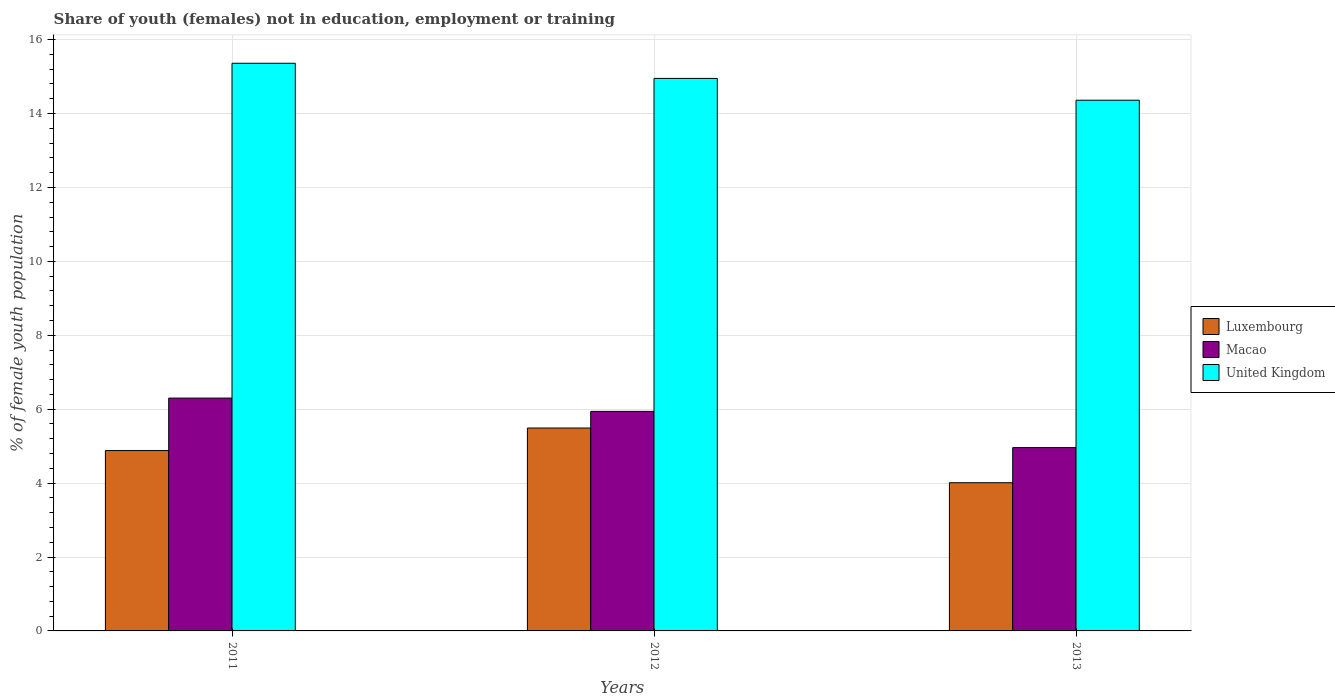How many bars are there on the 2nd tick from the left?
Make the answer very short. 3. What is the label of the 2nd group of bars from the left?
Your response must be concise. 2012. In how many cases, is the number of bars for a given year not equal to the number of legend labels?
Your answer should be very brief. 0. What is the percentage of unemployed female population in in United Kingdom in 2013?
Keep it short and to the point. 14.36. Across all years, what is the maximum percentage of unemployed female population in in Macao?
Provide a succinct answer. 6.3. Across all years, what is the minimum percentage of unemployed female population in in Macao?
Your response must be concise. 4.96. What is the total percentage of unemployed female population in in United Kingdom in the graph?
Your response must be concise. 44.67. What is the difference between the percentage of unemployed female population in in United Kingdom in 2011 and that in 2012?
Your response must be concise. 0.41. What is the difference between the percentage of unemployed female population in in Luxembourg in 2011 and the percentage of unemployed female population in in Macao in 2012?
Provide a succinct answer. -1.06. What is the average percentage of unemployed female population in in Luxembourg per year?
Offer a terse response. 4.79. In the year 2012, what is the difference between the percentage of unemployed female population in in Luxembourg and percentage of unemployed female population in in Macao?
Keep it short and to the point. -0.45. In how many years, is the percentage of unemployed female population in in Luxembourg greater than 12.8 %?
Provide a succinct answer. 0. What is the ratio of the percentage of unemployed female population in in Luxembourg in 2012 to that in 2013?
Keep it short and to the point. 1.37. Is the percentage of unemployed female population in in United Kingdom in 2012 less than that in 2013?
Offer a terse response. No. Is the difference between the percentage of unemployed female population in in Luxembourg in 2011 and 2012 greater than the difference between the percentage of unemployed female population in in Macao in 2011 and 2012?
Your answer should be very brief. No. What is the difference between the highest and the second highest percentage of unemployed female population in in Macao?
Make the answer very short. 0.36. What is the difference between the highest and the lowest percentage of unemployed female population in in Luxembourg?
Your response must be concise. 1.48. In how many years, is the percentage of unemployed female population in in United Kingdom greater than the average percentage of unemployed female population in in United Kingdom taken over all years?
Keep it short and to the point. 2. Is the sum of the percentage of unemployed female population in in Macao in 2011 and 2012 greater than the maximum percentage of unemployed female population in in Luxembourg across all years?
Your answer should be compact. Yes. What does the 2nd bar from the left in 2013 represents?
Offer a very short reply. Macao. What does the 1st bar from the right in 2012 represents?
Make the answer very short. United Kingdom. Is it the case that in every year, the sum of the percentage of unemployed female population in in Macao and percentage of unemployed female population in in Luxembourg is greater than the percentage of unemployed female population in in United Kingdom?
Your answer should be very brief. No. How many years are there in the graph?
Ensure brevity in your answer.  3. What is the difference between two consecutive major ticks on the Y-axis?
Ensure brevity in your answer.  2. Are the values on the major ticks of Y-axis written in scientific E-notation?
Offer a terse response. No. What is the title of the graph?
Your answer should be very brief. Share of youth (females) not in education, employment or training. Does "Low & middle income" appear as one of the legend labels in the graph?
Offer a terse response. No. What is the label or title of the X-axis?
Give a very brief answer. Years. What is the label or title of the Y-axis?
Your answer should be very brief. % of female youth population. What is the % of female youth population in Luxembourg in 2011?
Offer a terse response. 4.88. What is the % of female youth population of Macao in 2011?
Give a very brief answer. 6.3. What is the % of female youth population in United Kingdom in 2011?
Your answer should be compact. 15.36. What is the % of female youth population of Luxembourg in 2012?
Offer a terse response. 5.49. What is the % of female youth population in Macao in 2012?
Your answer should be very brief. 5.94. What is the % of female youth population in United Kingdom in 2012?
Keep it short and to the point. 14.95. What is the % of female youth population of Luxembourg in 2013?
Ensure brevity in your answer.  4.01. What is the % of female youth population in Macao in 2013?
Give a very brief answer. 4.96. What is the % of female youth population of United Kingdom in 2013?
Make the answer very short. 14.36. Across all years, what is the maximum % of female youth population in Luxembourg?
Make the answer very short. 5.49. Across all years, what is the maximum % of female youth population in Macao?
Your answer should be very brief. 6.3. Across all years, what is the maximum % of female youth population of United Kingdom?
Offer a very short reply. 15.36. Across all years, what is the minimum % of female youth population in Luxembourg?
Keep it short and to the point. 4.01. Across all years, what is the minimum % of female youth population in Macao?
Offer a terse response. 4.96. Across all years, what is the minimum % of female youth population in United Kingdom?
Make the answer very short. 14.36. What is the total % of female youth population in Luxembourg in the graph?
Your answer should be very brief. 14.38. What is the total % of female youth population of Macao in the graph?
Offer a terse response. 17.2. What is the total % of female youth population in United Kingdom in the graph?
Keep it short and to the point. 44.67. What is the difference between the % of female youth population of Luxembourg in 2011 and that in 2012?
Your answer should be very brief. -0.61. What is the difference between the % of female youth population in Macao in 2011 and that in 2012?
Provide a short and direct response. 0.36. What is the difference between the % of female youth population in United Kingdom in 2011 and that in 2012?
Give a very brief answer. 0.41. What is the difference between the % of female youth population of Luxembourg in 2011 and that in 2013?
Keep it short and to the point. 0.87. What is the difference between the % of female youth population of Macao in 2011 and that in 2013?
Provide a short and direct response. 1.34. What is the difference between the % of female youth population of Luxembourg in 2012 and that in 2013?
Ensure brevity in your answer.  1.48. What is the difference between the % of female youth population of Macao in 2012 and that in 2013?
Ensure brevity in your answer.  0.98. What is the difference between the % of female youth population of United Kingdom in 2012 and that in 2013?
Provide a short and direct response. 0.59. What is the difference between the % of female youth population in Luxembourg in 2011 and the % of female youth population in Macao in 2012?
Offer a terse response. -1.06. What is the difference between the % of female youth population of Luxembourg in 2011 and the % of female youth population of United Kingdom in 2012?
Your answer should be very brief. -10.07. What is the difference between the % of female youth population of Macao in 2011 and the % of female youth population of United Kingdom in 2012?
Provide a short and direct response. -8.65. What is the difference between the % of female youth population in Luxembourg in 2011 and the % of female youth population in Macao in 2013?
Keep it short and to the point. -0.08. What is the difference between the % of female youth population of Luxembourg in 2011 and the % of female youth population of United Kingdom in 2013?
Offer a very short reply. -9.48. What is the difference between the % of female youth population of Macao in 2011 and the % of female youth population of United Kingdom in 2013?
Offer a very short reply. -8.06. What is the difference between the % of female youth population of Luxembourg in 2012 and the % of female youth population of Macao in 2013?
Your response must be concise. 0.53. What is the difference between the % of female youth population of Luxembourg in 2012 and the % of female youth population of United Kingdom in 2013?
Your response must be concise. -8.87. What is the difference between the % of female youth population of Macao in 2012 and the % of female youth population of United Kingdom in 2013?
Give a very brief answer. -8.42. What is the average % of female youth population in Luxembourg per year?
Make the answer very short. 4.79. What is the average % of female youth population in Macao per year?
Offer a terse response. 5.73. What is the average % of female youth population of United Kingdom per year?
Ensure brevity in your answer.  14.89. In the year 2011, what is the difference between the % of female youth population of Luxembourg and % of female youth population of Macao?
Provide a succinct answer. -1.42. In the year 2011, what is the difference between the % of female youth population of Luxembourg and % of female youth population of United Kingdom?
Provide a short and direct response. -10.48. In the year 2011, what is the difference between the % of female youth population of Macao and % of female youth population of United Kingdom?
Provide a succinct answer. -9.06. In the year 2012, what is the difference between the % of female youth population of Luxembourg and % of female youth population of Macao?
Your answer should be compact. -0.45. In the year 2012, what is the difference between the % of female youth population of Luxembourg and % of female youth population of United Kingdom?
Give a very brief answer. -9.46. In the year 2012, what is the difference between the % of female youth population in Macao and % of female youth population in United Kingdom?
Keep it short and to the point. -9.01. In the year 2013, what is the difference between the % of female youth population of Luxembourg and % of female youth population of Macao?
Your response must be concise. -0.95. In the year 2013, what is the difference between the % of female youth population of Luxembourg and % of female youth population of United Kingdom?
Provide a short and direct response. -10.35. What is the ratio of the % of female youth population of Macao in 2011 to that in 2012?
Ensure brevity in your answer.  1.06. What is the ratio of the % of female youth population in United Kingdom in 2011 to that in 2012?
Offer a terse response. 1.03. What is the ratio of the % of female youth population in Luxembourg in 2011 to that in 2013?
Give a very brief answer. 1.22. What is the ratio of the % of female youth population of Macao in 2011 to that in 2013?
Give a very brief answer. 1.27. What is the ratio of the % of female youth population in United Kingdom in 2011 to that in 2013?
Offer a terse response. 1.07. What is the ratio of the % of female youth population of Luxembourg in 2012 to that in 2013?
Your answer should be very brief. 1.37. What is the ratio of the % of female youth population of Macao in 2012 to that in 2013?
Provide a short and direct response. 1.2. What is the ratio of the % of female youth population in United Kingdom in 2012 to that in 2013?
Your response must be concise. 1.04. What is the difference between the highest and the second highest % of female youth population in Luxembourg?
Provide a succinct answer. 0.61. What is the difference between the highest and the second highest % of female youth population in Macao?
Provide a succinct answer. 0.36. What is the difference between the highest and the second highest % of female youth population of United Kingdom?
Keep it short and to the point. 0.41. What is the difference between the highest and the lowest % of female youth population of Luxembourg?
Provide a succinct answer. 1.48. What is the difference between the highest and the lowest % of female youth population of Macao?
Your answer should be compact. 1.34. What is the difference between the highest and the lowest % of female youth population in United Kingdom?
Your answer should be compact. 1. 